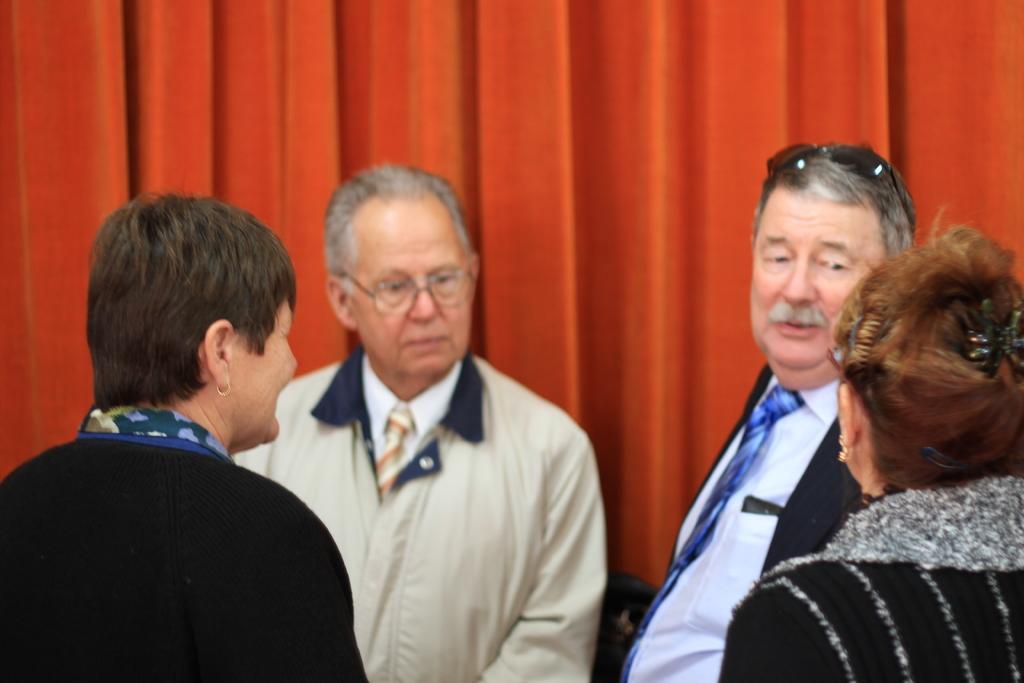Could you give a brief overview of what you see in this image? In this image we can see few persons and in the background we can see a curtain. 